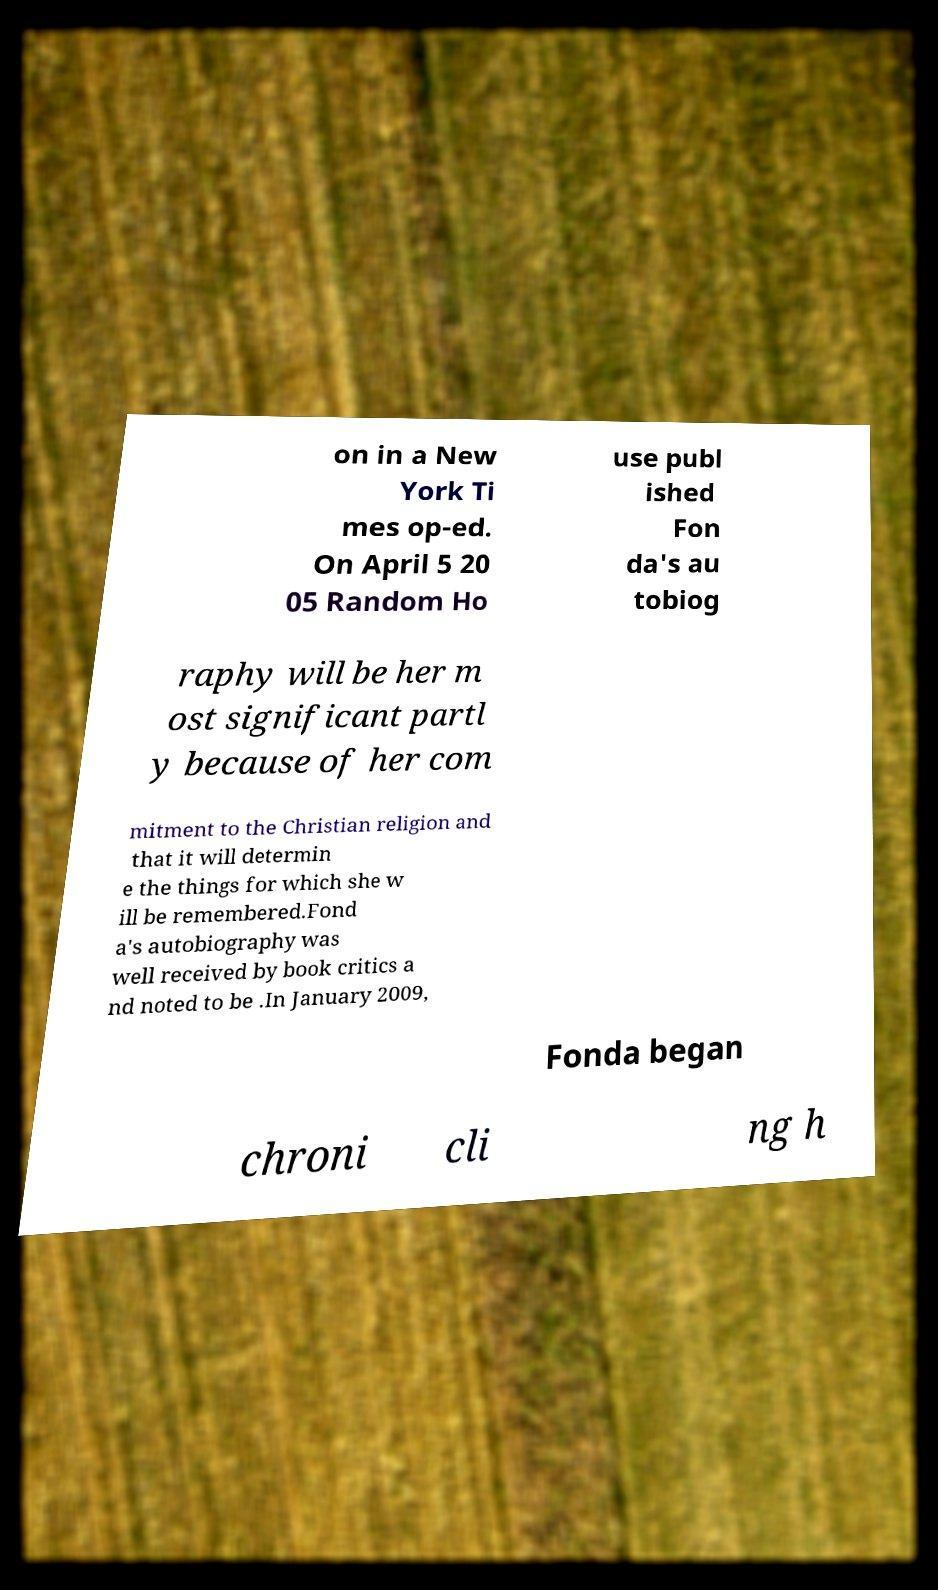What messages or text are displayed in this image? I need them in a readable, typed format. on in a New York Ti mes op-ed. On April 5 20 05 Random Ho use publ ished Fon da's au tobiog raphy will be her m ost significant partl y because of her com mitment to the Christian religion and that it will determin e the things for which she w ill be remembered.Fond a's autobiography was well received by book critics a nd noted to be .In January 2009, Fonda began chroni cli ng h 